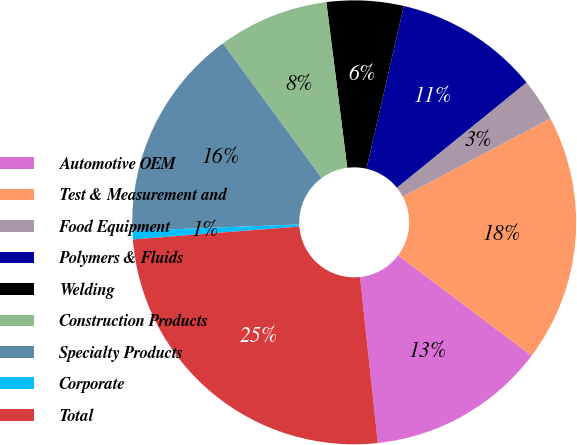Convert chart to OTSL. <chart><loc_0><loc_0><loc_500><loc_500><pie_chart><fcel>Automotive OEM<fcel>Test & Measurement and<fcel>Food Equipment<fcel>Polymers & Fluids<fcel>Welding<fcel>Construction Products<fcel>Specialty Products<fcel>Corporate<fcel>Total<nl><fcel>13.04%<fcel>18.01%<fcel>3.1%<fcel>10.56%<fcel>5.59%<fcel>8.07%<fcel>15.53%<fcel>0.62%<fcel>25.47%<nl></chart> 